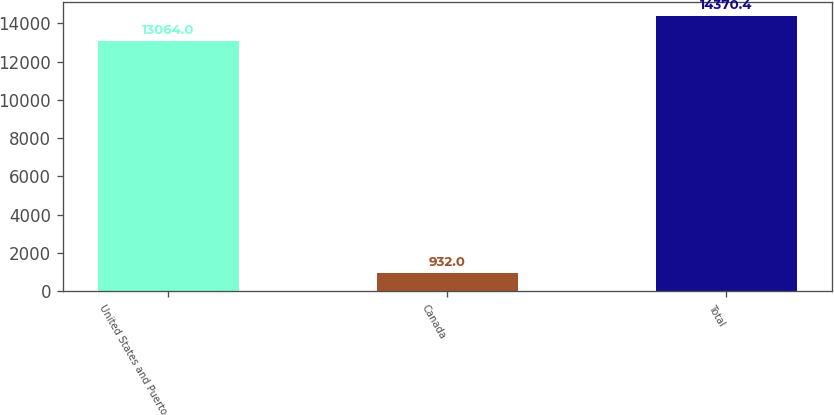Convert chart to OTSL. <chart><loc_0><loc_0><loc_500><loc_500><bar_chart><fcel>United States and Puerto<fcel>Canada<fcel>Total<nl><fcel>13064<fcel>932<fcel>14370.4<nl></chart> 